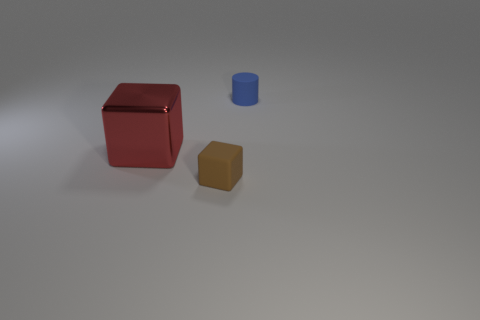Subtract all cylinders. How many objects are left? 2 Add 1 red cubes. How many red cubes exist? 2 Add 3 small red metal cylinders. How many objects exist? 6 Subtract 0 green cubes. How many objects are left? 3 Subtract 1 blocks. How many blocks are left? 1 Subtract all brown cubes. Subtract all yellow cylinders. How many cubes are left? 1 Subtract all cyan cylinders. How many cyan blocks are left? 0 Subtract all blocks. Subtract all blue objects. How many objects are left? 0 Add 2 rubber blocks. How many rubber blocks are left? 3 